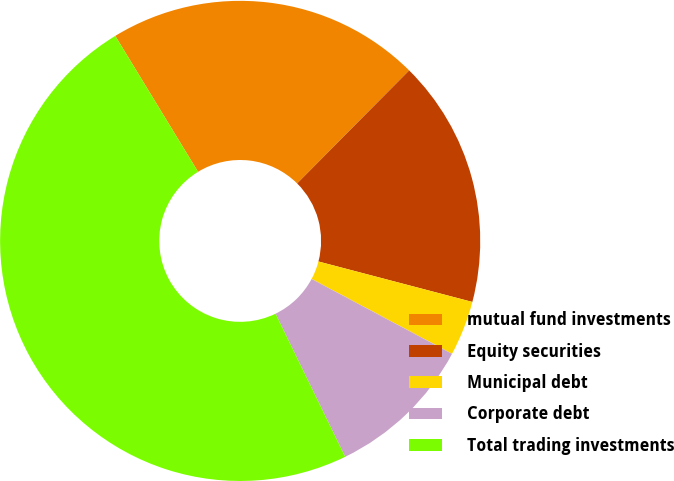Convert chart to OTSL. <chart><loc_0><loc_0><loc_500><loc_500><pie_chart><fcel>mutual fund investments<fcel>Equity securities<fcel>Municipal debt<fcel>Corporate debt<fcel>Total trading investments<nl><fcel>21.14%<fcel>16.66%<fcel>3.7%<fcel>10.0%<fcel>48.5%<nl></chart> 